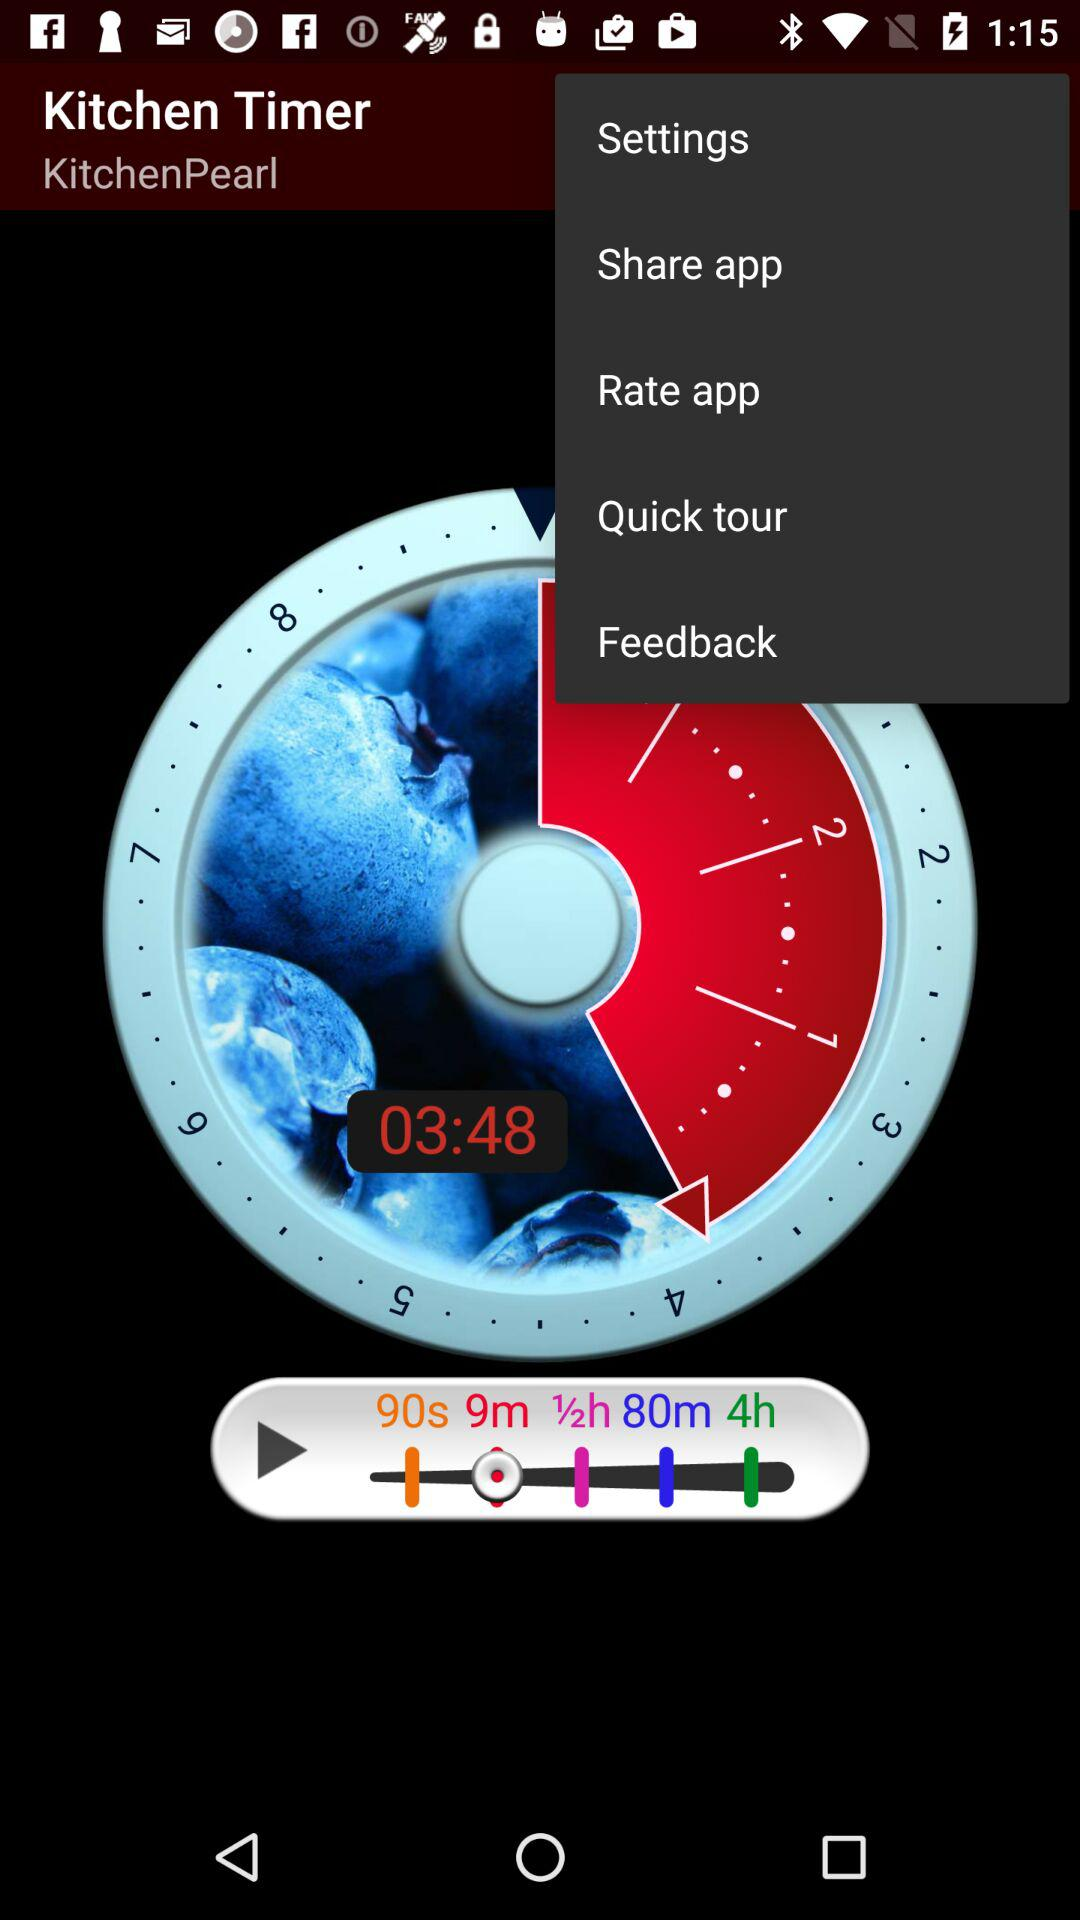What is the application name? The name of the application is "Kitchen Timer". 